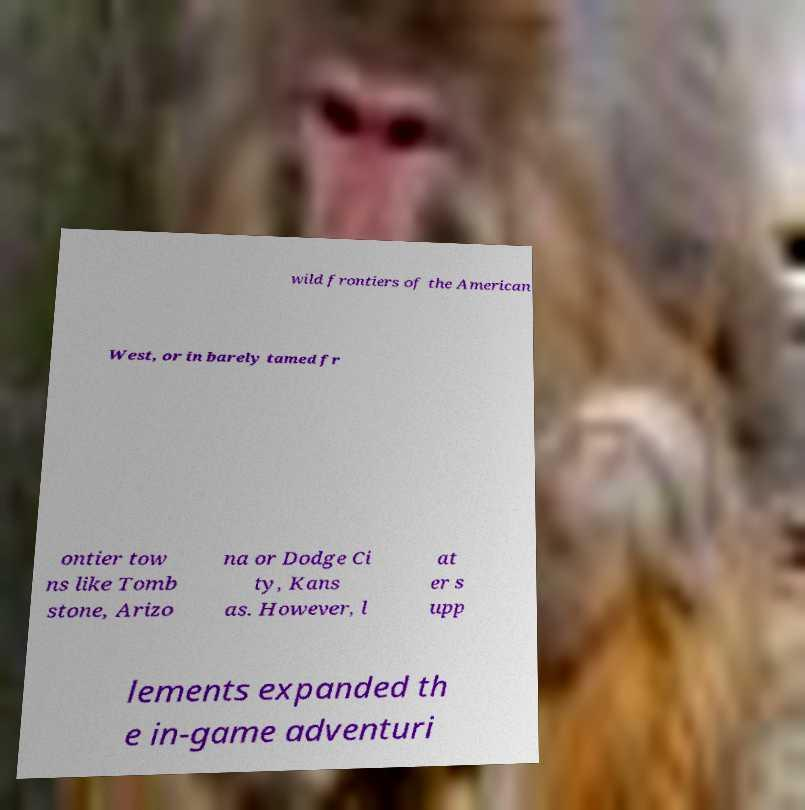Could you extract and type out the text from this image? wild frontiers of the American West, or in barely tamed fr ontier tow ns like Tomb stone, Arizo na or Dodge Ci ty, Kans as. However, l at er s upp lements expanded th e in-game adventuri 